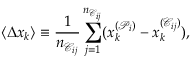Convert formula to latex. <formula><loc_0><loc_0><loc_500><loc_500>\langle \Delta x _ { k } \rangle \equiv \frac { 1 } { n _ { \mathcal { C } _ { i j } } } \sum _ { j = 1 } ^ { n _ { \mathcal { C } _ { i j } } } ( x _ { k } ^ { ( \mathcal { P } _ { i } ) } - x _ { k } ^ { ( \mathcal { C } _ { i j } ) } ) ,</formula> 